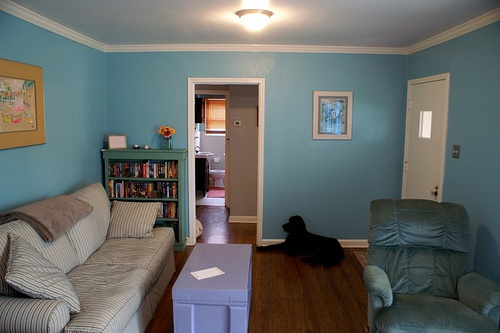Describe the objects in this image and their specific colors. I can see couch in gray and darkgray tones, chair in gray, black, and purple tones, book in gray and black tones, dog in gray, black, purple, and maroon tones, and book in gray, black, and maroon tones in this image. 